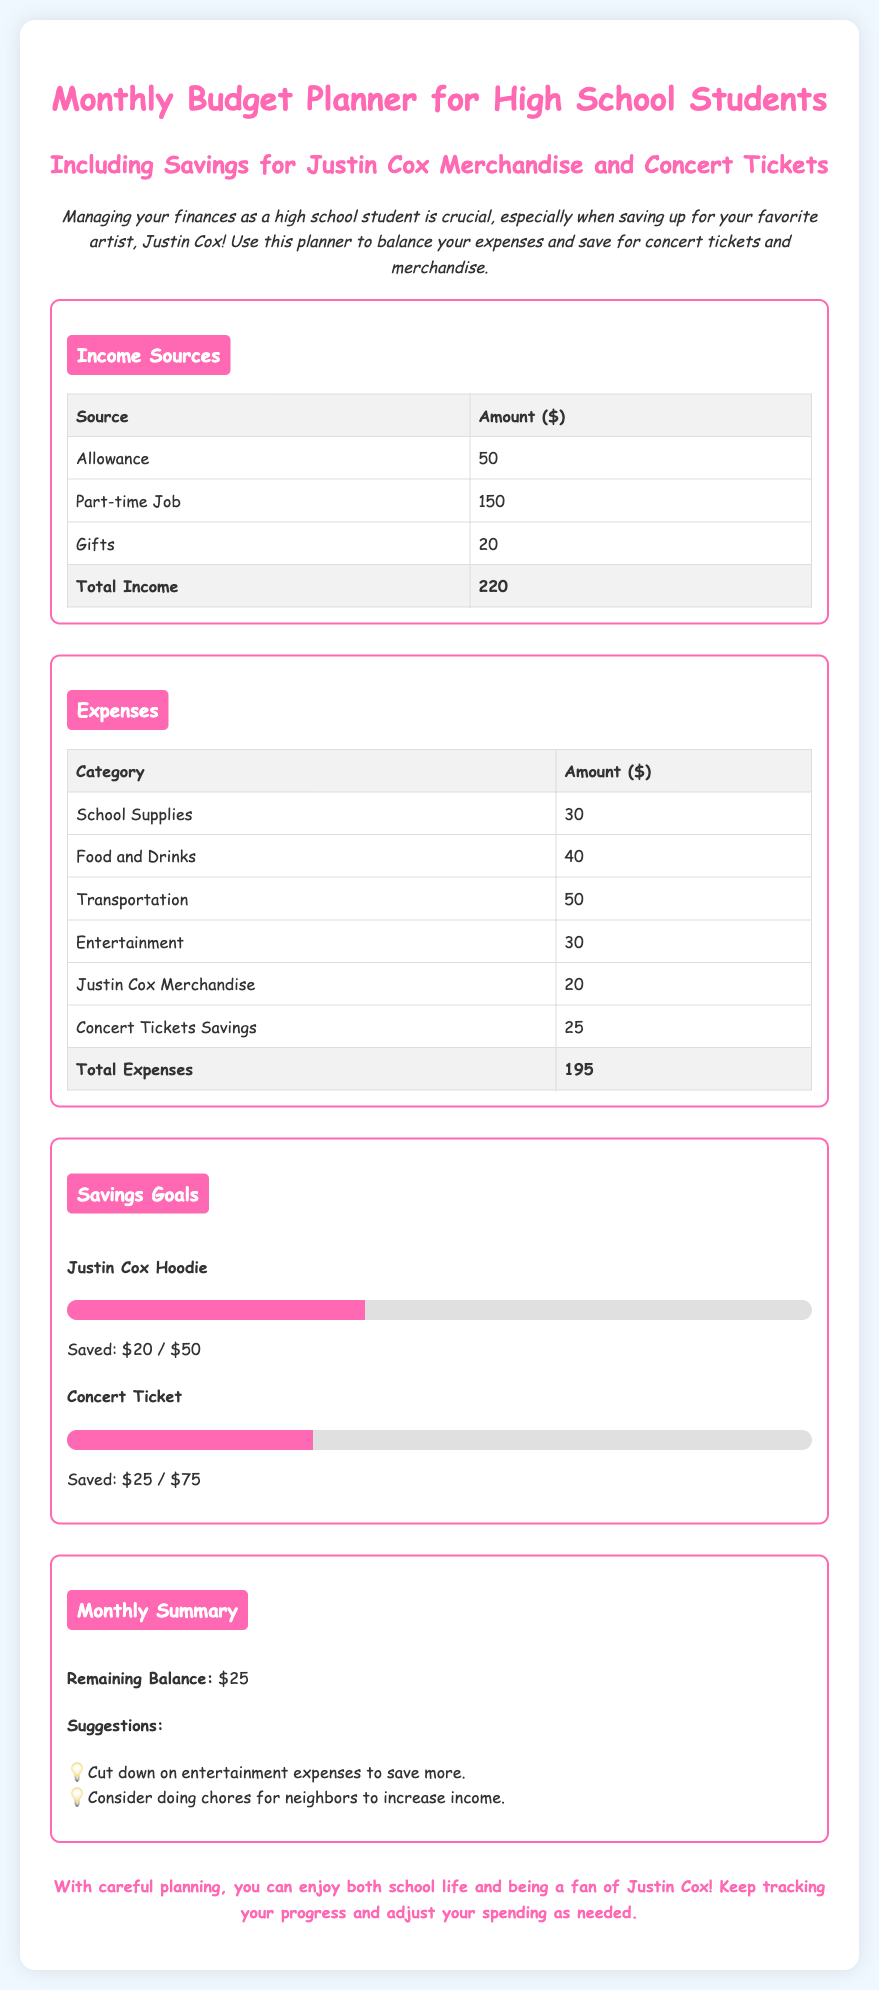What is the total income? The total income is derived from the sum of all income sources listed, which is $50 (Allowance) + $150 (Part-time Job) + $20 (Gifts) = $220.
Answer: $220 What is the total expense? The total expense is calculated from the sum of all expense categories, which is $30 (School Supplies) + $40 (Food and Drinks) + $50 (Transportation) + $30 (Entertainment) + $20 (Justin Cox Merchandise) + $25 (Concert Tickets Savings) = $195.
Answer: $195 How much money is saved for the Justin Cox Hoodie? The saved amount for the Justin Cox Hoodie is mentioned in the Savings Goals section, indicating $20 has been saved out of a goal of $50.
Answer: $20 What percentage of the concert ticket goal is saved? The progress bar for the concert ticket indicates that 33% of the saving goal has been achieved, contributing to a total saved amount of $25.
Answer: 33% What is the remaining balance after expenses? The document states that after accounting for total income and expenses, the remaining balance is $25.
Answer: $25 What suggestion is provided to save more money? One suggestion mentioned in the Monthly Summary section is to cut down on entertainment expenses to save more.
Answer: Cut down on entertainment How much is allocated for Justin Cox Merchandise? The planned amount for Justin Cox Merchandise is listed in the Expenses section as $20.
Answer: $20 What color is used for the section titles? The section titles are colored in a shade of pink, specifically #ff69b4.
Answer: Pink What is the total savings goal for concert tickets? The total saving goal for concert tickets is identified in the document as $75.
Answer: $75 